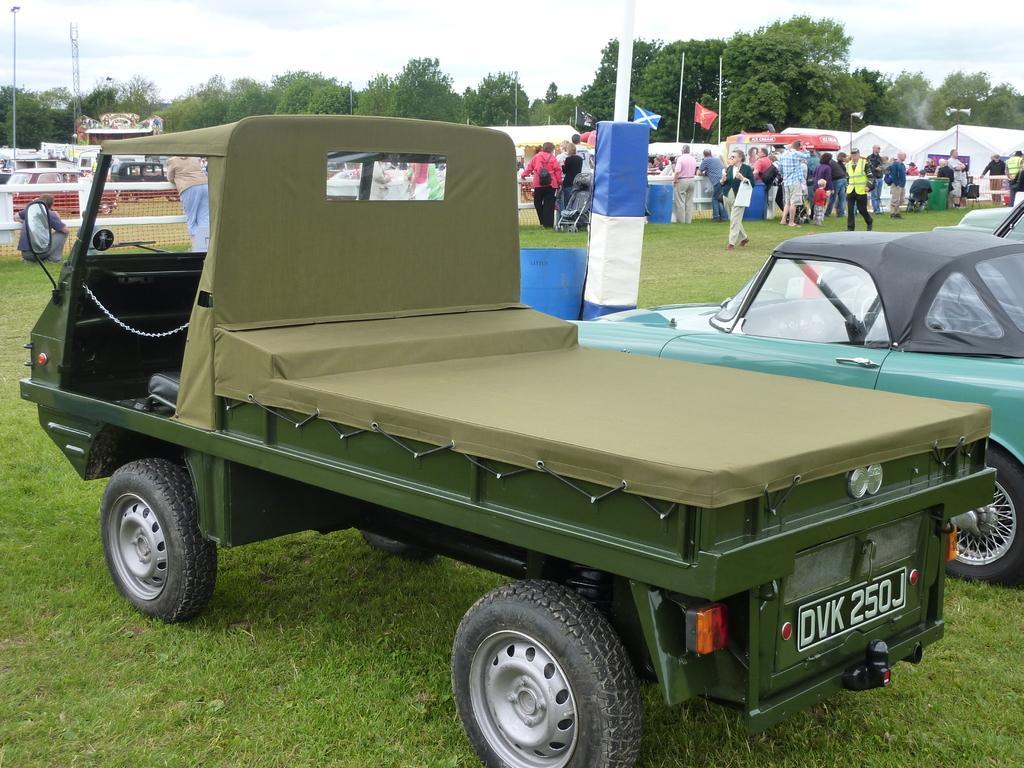Please provide a concise description of this image. In this image I can see few vehicles, trees, poles, net fencing, flags, tents, few people are standing and few people are walking. The sky is in white and blue color. 